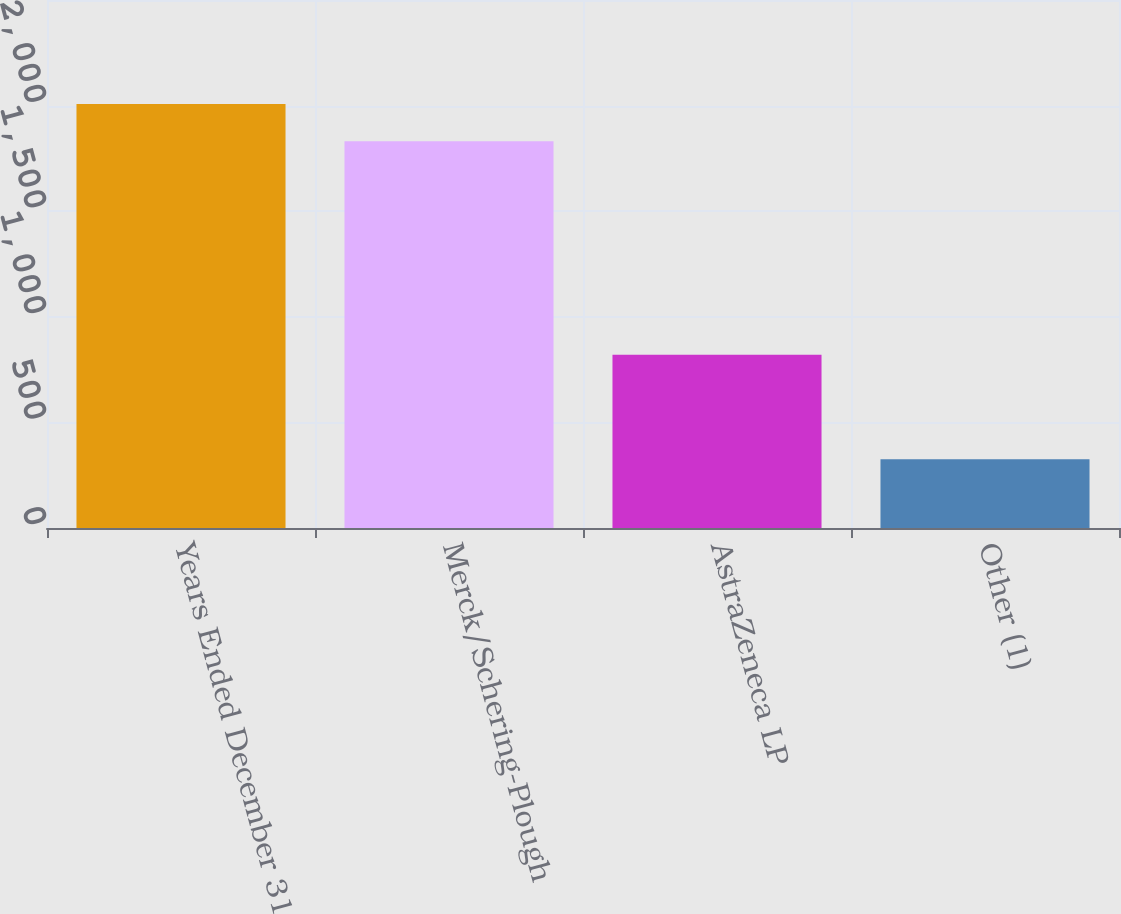<chart> <loc_0><loc_0><loc_500><loc_500><bar_chart><fcel>Years Ended December 31<fcel>Merck/Schering-Plough<fcel>AstraZeneca LP<fcel>Other (1)<nl><fcel>2007<fcel>1830.8<fcel>820.1<fcel>325.6<nl></chart> 